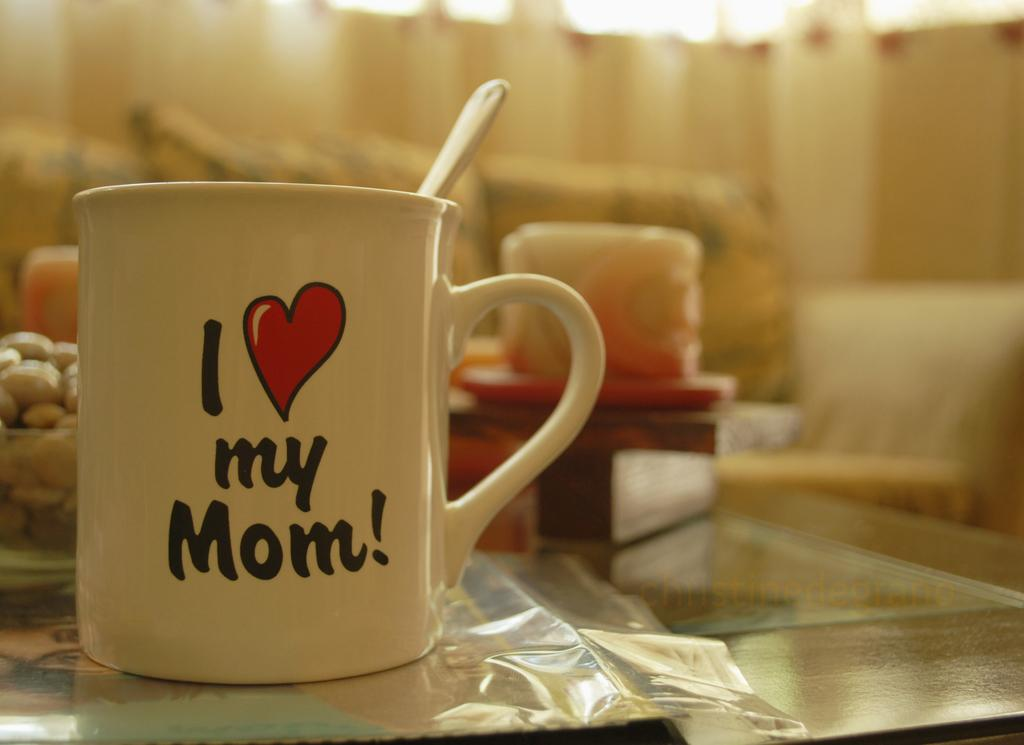<image>
Share a concise interpretation of the image provided. A mug on a living room table that says I love my mom. 